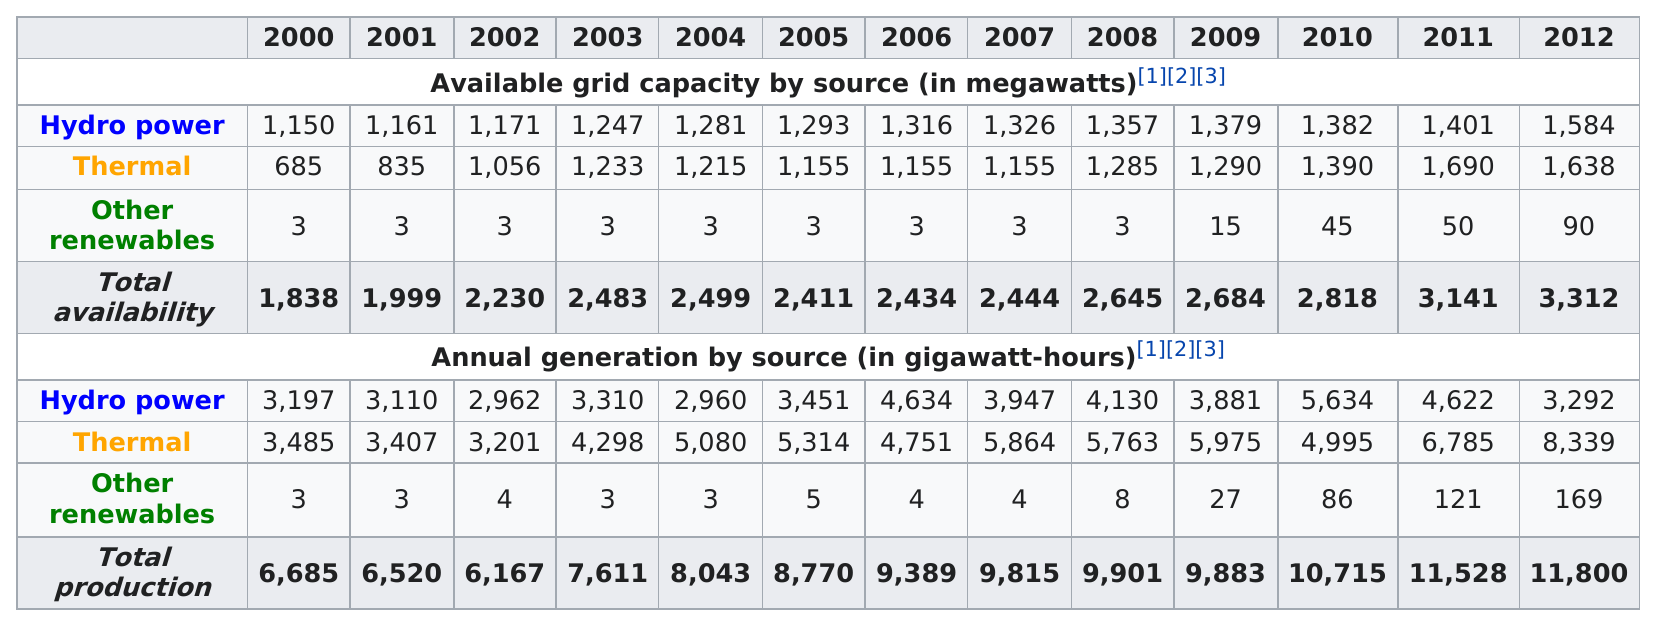Point out several critical features in this image. In the year 2000, the thermal grid capacity was at its lowest. For how many years has hydro power generated over 4,000 megawatt-hours annually? From 2010 to 2012, hydro power increased. In 2007, other renewables were found to have the least amount of capacity among all types of power sources. In 2000 and 2001, the total megawatts generated was 161 megawatts greater than the combined total in those two years. 